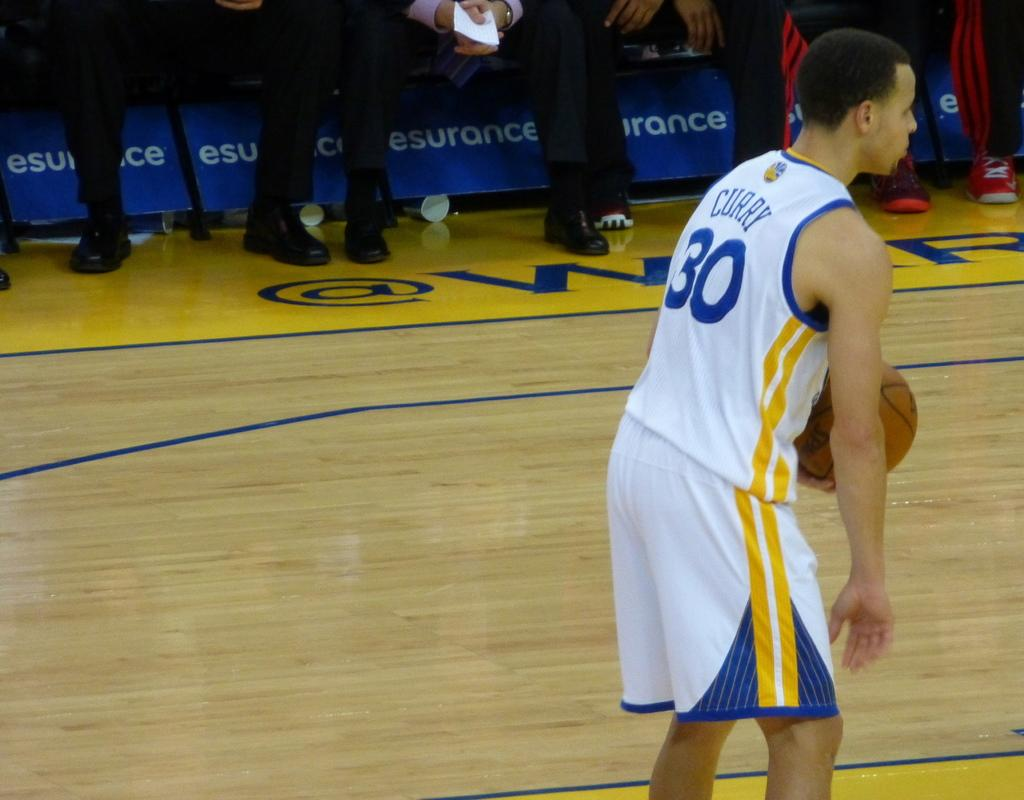<image>
Offer a succinct explanation of the picture presented. The young player Curry currently has the ball. 